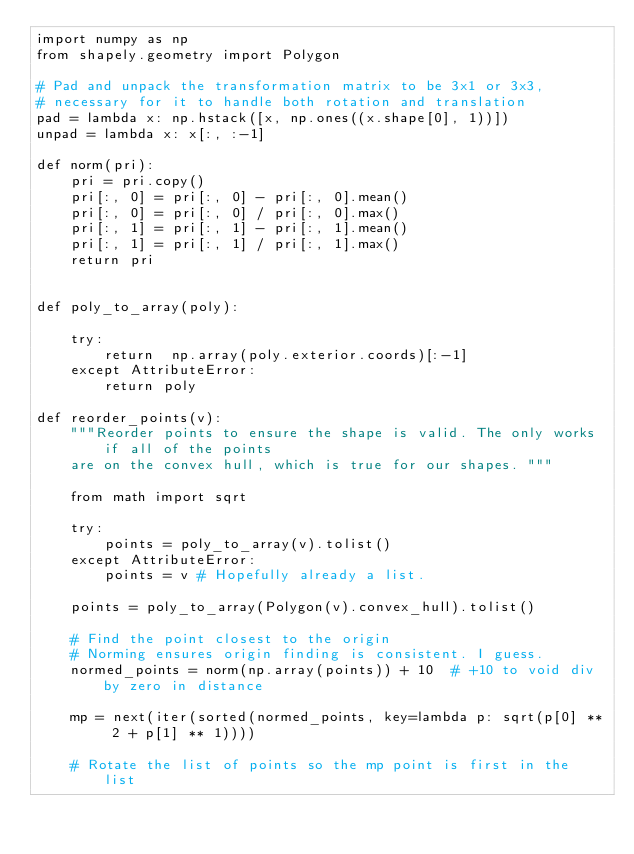<code> <loc_0><loc_0><loc_500><loc_500><_Python_>import numpy as np
from shapely.geometry import Polygon

# Pad and unpack the transformation matrix to be 3x1 or 3x3,
# necessary for it to handle both rotation and translation
pad = lambda x: np.hstack([x, np.ones((x.shape[0], 1))])
unpad = lambda x: x[:, :-1]

def norm(pri):
    pri = pri.copy()
    pri[:, 0] = pri[:, 0] - pri[:, 0].mean()
    pri[:, 0] = pri[:, 0] / pri[:, 0].max()
    pri[:, 1] = pri[:, 1] - pri[:, 1].mean()
    pri[:, 1] = pri[:, 1] / pri[:, 1].max()
    return pri


def poly_to_array(poly):

    try:
        return  np.array(poly.exterior.coords)[:-1]
    except AttributeError:
        return poly

def reorder_points(v):
    """Reorder points to ensure the shape is valid. The only works if all of the points
    are on the convex hull, which is true for our shapes. """

    from math import sqrt

    try:
        points = poly_to_array(v).tolist()
    except AttributeError:
        points = v # Hopefully already a list.

    points = poly_to_array(Polygon(v).convex_hull).tolist()

    # Find the point closest to the origin
    # Norming ensures origin finding is consistent. I guess.
    normed_points = norm(np.array(points)) + 10  # +10 to void div by zero in distance

    mp = next(iter(sorted(normed_points, key=lambda p: sqrt(p[0] ** 2 + p[1] ** 1))))

    # Rotate the list of points so the mp point is first in the list</code> 